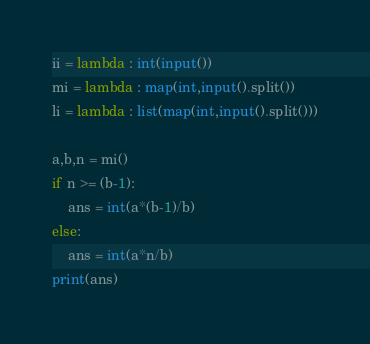<code> <loc_0><loc_0><loc_500><loc_500><_Python_>ii = lambda : int(input())
mi = lambda : map(int,input().split())
li = lambda : list(map(int,input().split()))

a,b,n = mi()
if n >= (b-1):
    ans = int(a*(b-1)/b)
else:
    ans = int(a*n/b)
print(ans)

</code> 